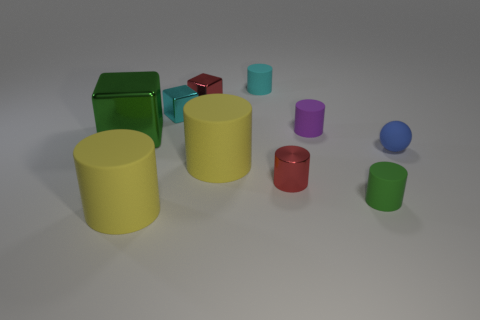How might these objects be utilized in a learning environment? In a learning environment, these objects can be used to teach a variety of concepts such as colors, shapes, size comparison, and spatial relationships. They can also be used for exercises in counting or simple physics demonstrations, like showcasing how different shapes roll or don't roll. 